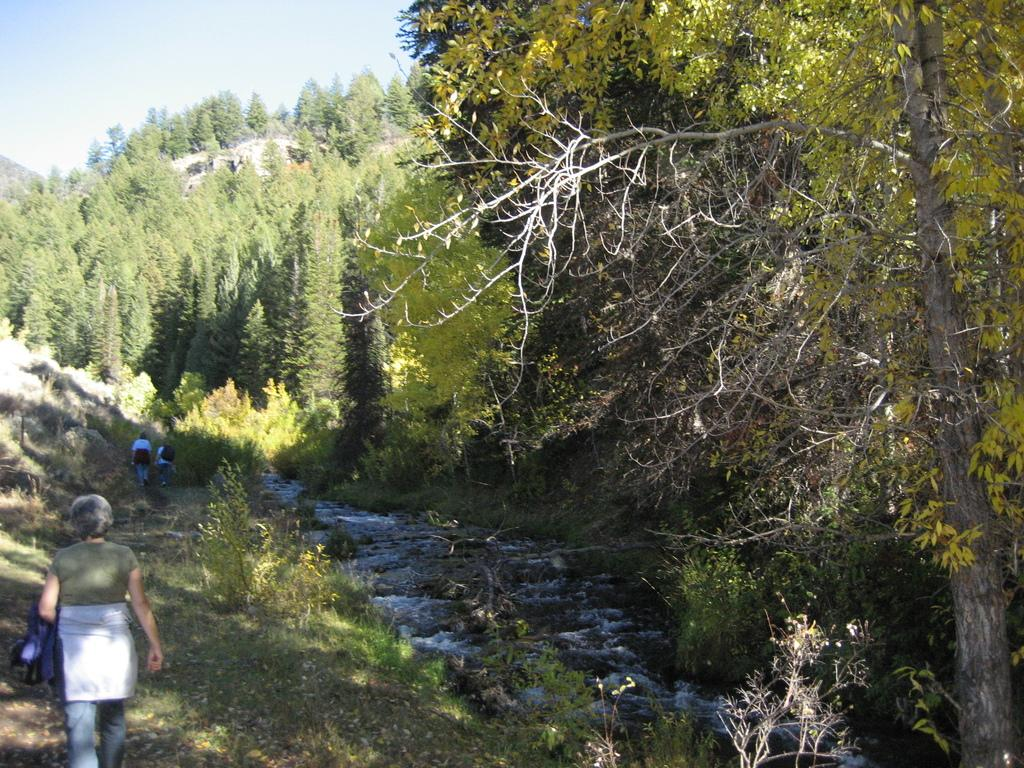How many people are in the image? There are three persons in the image. What are the persons doing in the image? The persons are walking on the ground. What type of vegetation can be seen in the image? There are trees and grass in the image. What is visible in the sky in the image? The sky is visible in the image. What natural element can be seen in the image besides vegetation? There is water visible in the image. What type of cord is being used by the persons in the image? There is no cord visible in the image; the persons are walking on the ground. What time of day is it in the image, based on the hour? The provided facts do not mention the time of day or any specific hour, so it cannot be determined from the image. 